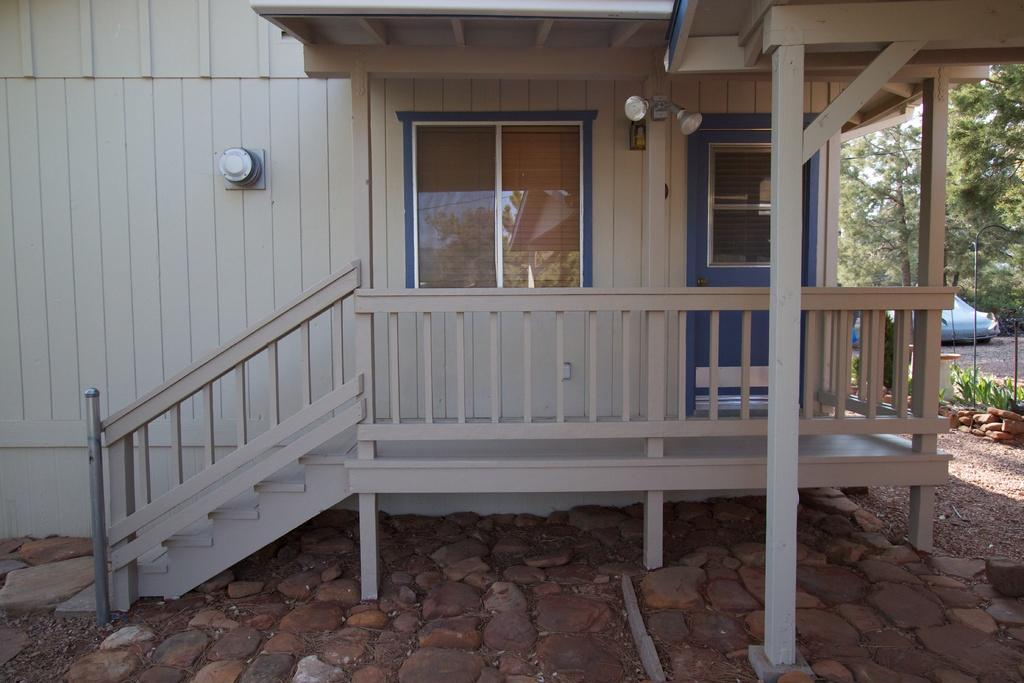What type of structure is visible in the image? There is a building in the image. What natural elements can be seen in the image? There are trees and plants in the image. What type of ground surface is visible in the image? There are rocks on the ground in the image. What architectural features are present in the image? There is a glass door and a glass window in the image. What type of lace can be seen on the glass door in the image? There is no lace present on the glass door in the image. What scene is depicted on the glass window in the image? There is no scene depicted on the glass window in the image; it is transparent. 